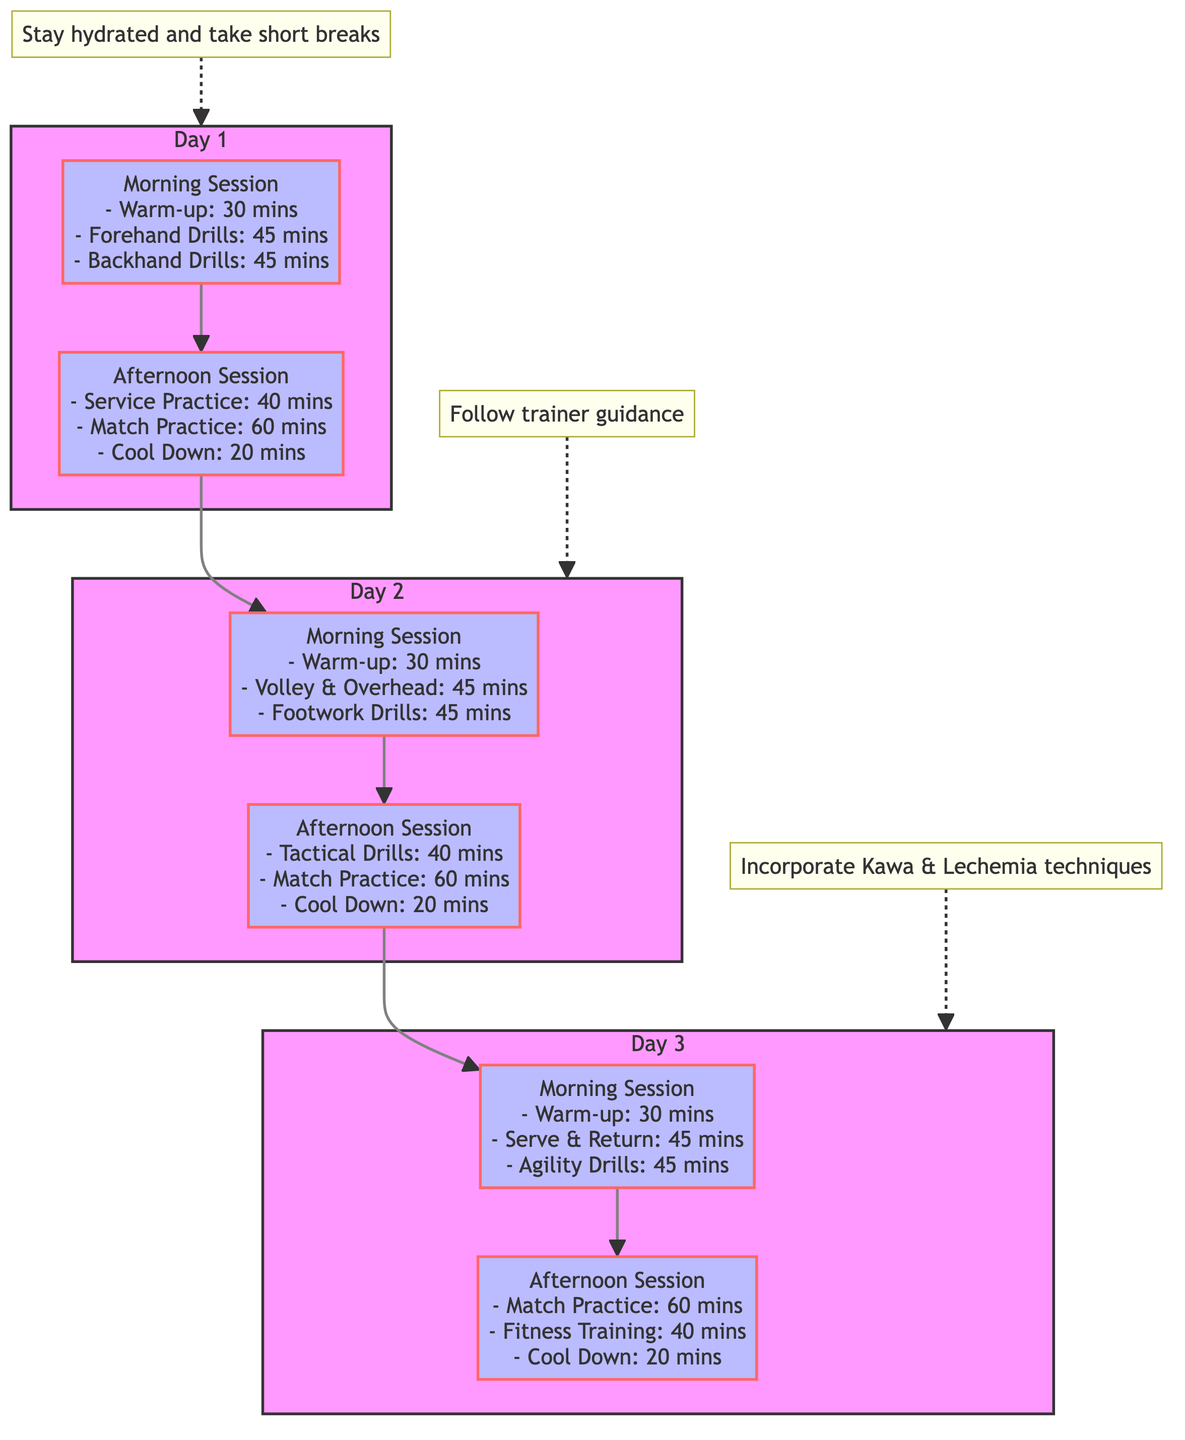What activities are in the morning session of Day 1? The morning session of Day 1 includes three activities: Warm-up for 30 minutes, Forehand Drills for 45 minutes, and Backhand Drills for 45 minutes. These activities are listed sequentially in the diagram.
Answer: Warm-up: 30 mins, Forehand Drills: 45 mins, Backhand Drills: 45 mins What is the total time allocated for Afternoon Sessions across all three days? Each Afternoon Session in the diagram has the following durations: Day 1 - 120 minutes, Day 2 - 120 minutes, and Day 3 - 120 minutes. Adding these totals gives 120 + 120 + 120 = 360 minutes.
Answer: 360 mins How many rest periods are there in the diagram? The diagram indicates that there are three rest notes associated with each day, but there are no specific indicated breaks between sessions. Therefore, the only rest-like notes are “Stay hydrated and take short breaks,” which is listed once for each day.
Answer: 3 Which day has Volley & Overhead drills in the morning session? Upon examining the diagram, the second day features Morning Session drills that include Volley & Overhead for 45 minutes as part of its schedule. Hence, Day 2 is the answer.
Answer: Day 2 What specific notes are mentioned in the diagram? The diagram includes three specific notes: "Stay hydrated and take short breaks," "Follow trainer guidance," and "Incorporate Kawa & Lechemia techniques." These notes differentiate between days and are strategically placed around the flow of activities.
Answer: Stay hydrated and take short breaks; Follow trainer guidance; Incorporate Kawa & Lechemia techniques What is the length of cool-down sessions in the diagram? Looking at the Afternoon Sessions for each day, the Cool Down is consistently listed as 20 minutes across all days. Thus, the duration for each cool-down session is uniform.
Answer: 20 mins 